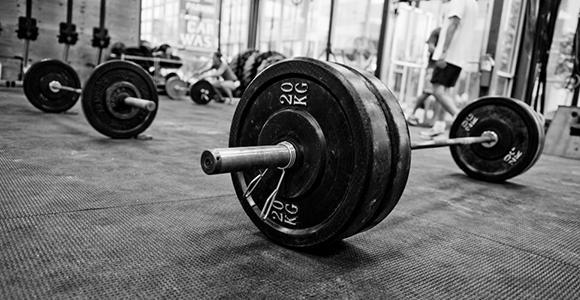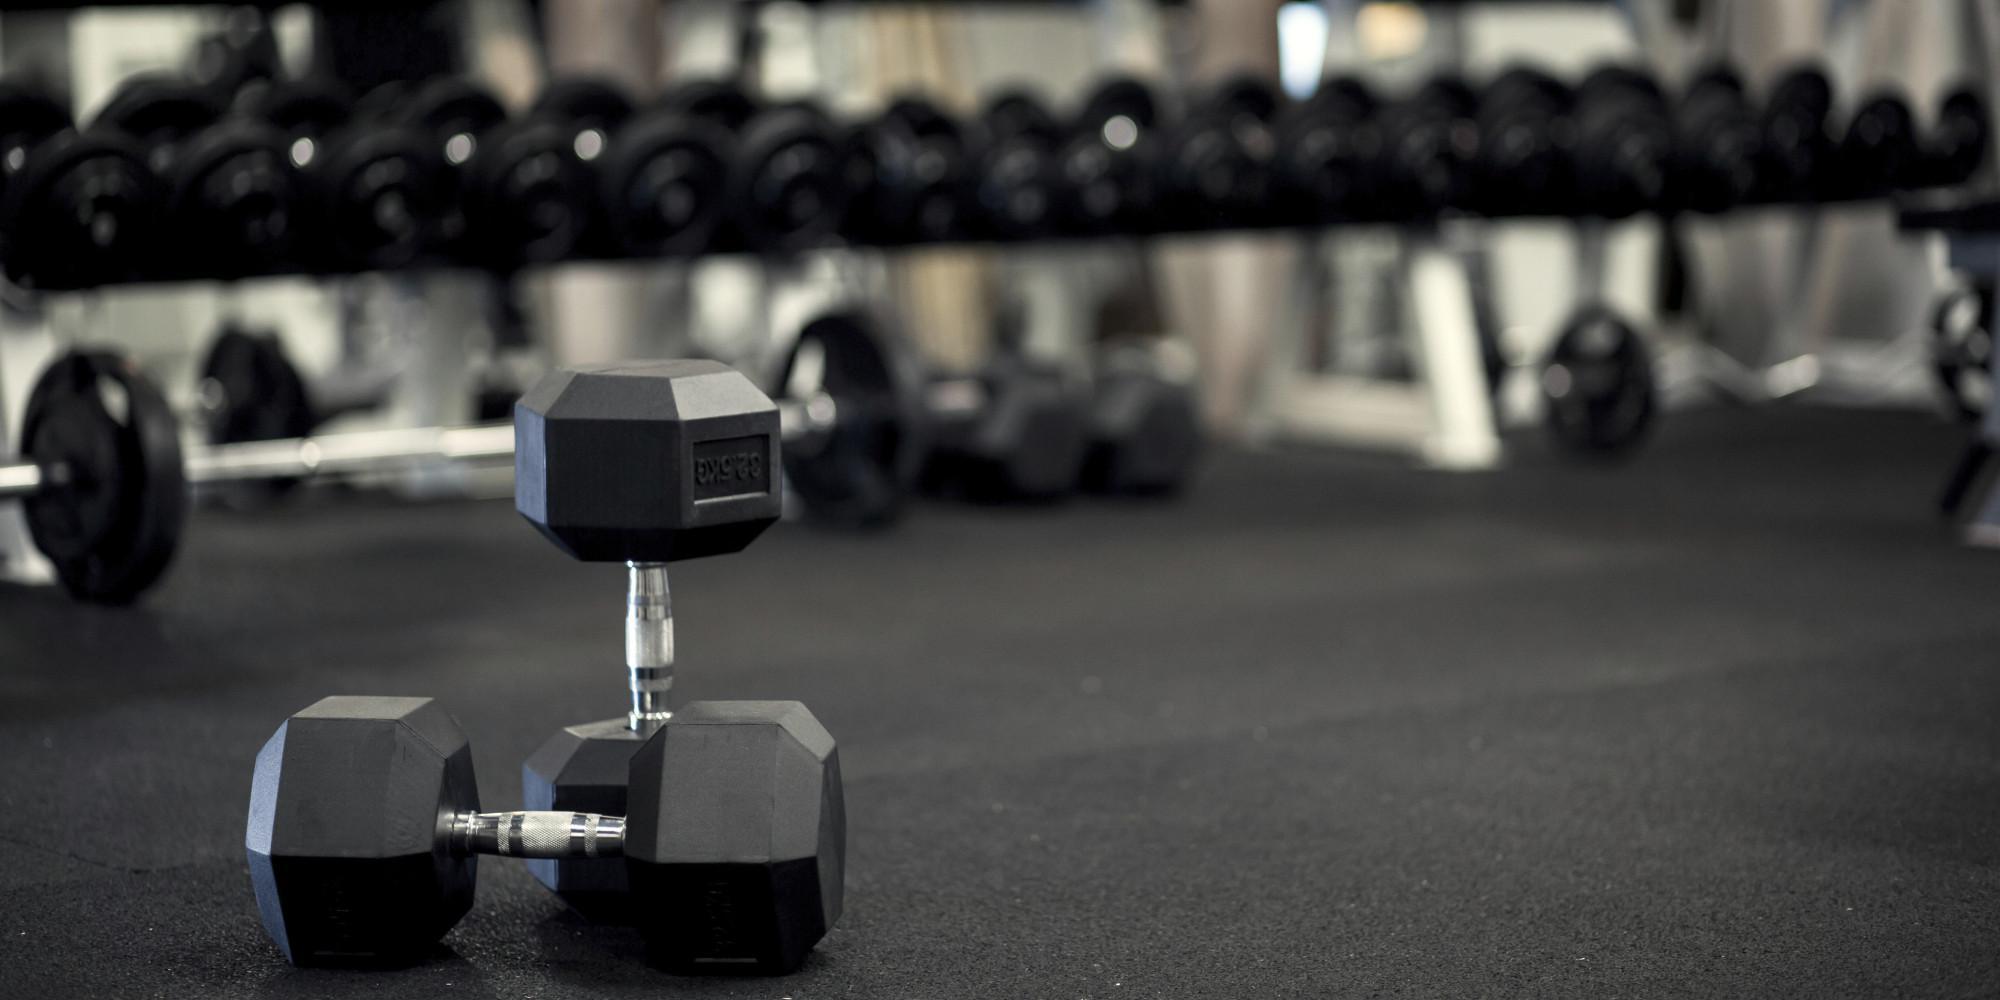The first image is the image on the left, the second image is the image on the right. For the images shown, is this caption "The dumbbells closest to the camera in one image have beveled edges instead of round edges." true? Answer yes or no. Yes. The first image is the image on the left, the second image is the image on the right. Assess this claim about the two images: "The round weights are sitting on the floor in one of the images.". Correct or not? Answer yes or no. Yes. 